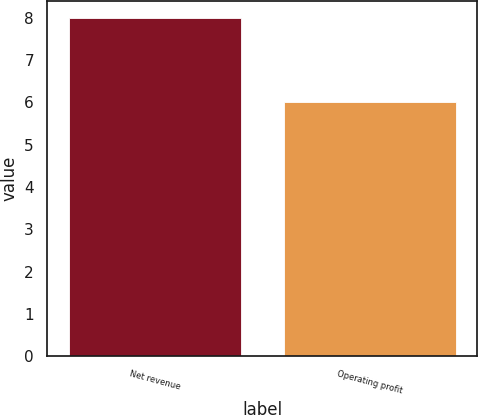Convert chart to OTSL. <chart><loc_0><loc_0><loc_500><loc_500><bar_chart><fcel>Net revenue<fcel>Operating profit<nl><fcel>8<fcel>6<nl></chart> 